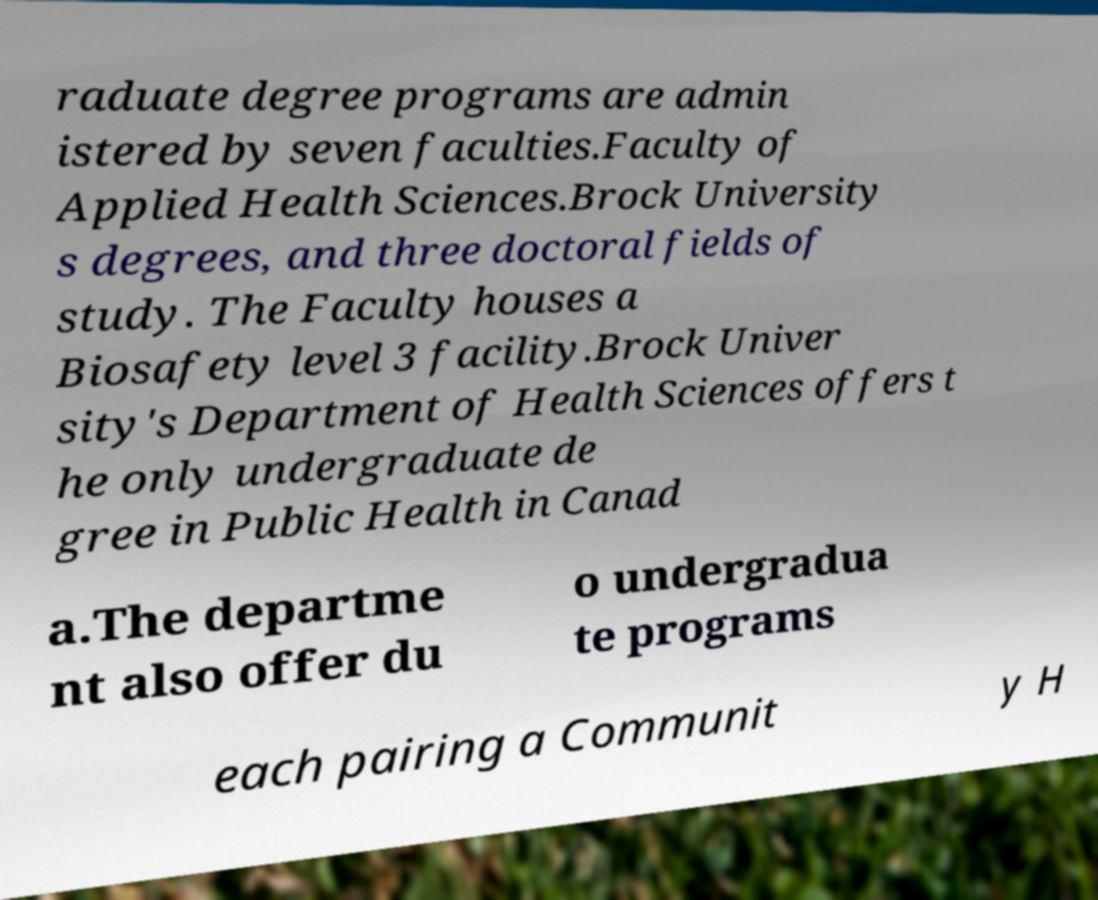What messages or text are displayed in this image? I need them in a readable, typed format. raduate degree programs are admin istered by seven faculties.Faculty of Applied Health Sciences.Brock University s degrees, and three doctoral fields of study. The Faculty houses a Biosafety level 3 facility.Brock Univer sity's Department of Health Sciences offers t he only undergraduate de gree in Public Health in Canad a.The departme nt also offer du o undergradua te programs each pairing a Communit y H 